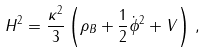Convert formula to latex. <formula><loc_0><loc_0><loc_500><loc_500>H ^ { 2 } = \frac { \kappa ^ { 2 } } { 3 } \left ( \rho _ { B } + \frac { 1 } { 2 } \dot { \phi } ^ { 2 } + V \right ) \, ,</formula> 